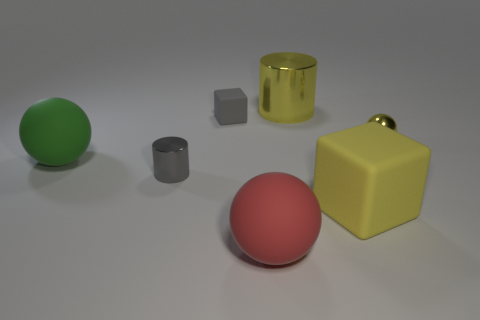There is a cylinder that is the same color as the small cube; what material is it?
Your answer should be compact. Metal. How many big things are the same material as the yellow sphere?
Keep it short and to the point. 1. The small cube that is made of the same material as the green object is what color?
Ensure brevity in your answer.  Gray. The big green thing is what shape?
Make the answer very short. Sphere. There is a sphere that is on the left side of the red rubber thing; what material is it?
Provide a short and direct response. Rubber. Is there a matte thing that has the same color as the small metallic cylinder?
Provide a succinct answer. Yes. What shape is the gray metallic object that is the same size as the shiny sphere?
Provide a short and direct response. Cylinder. The ball right of the yellow matte object is what color?
Keep it short and to the point. Yellow. Are there any big metallic things to the left of the big yellow object that is on the left side of the large yellow matte thing?
Your response must be concise. No. What number of things are either rubber objects on the left side of the gray block or gray matte spheres?
Offer a terse response. 1. 